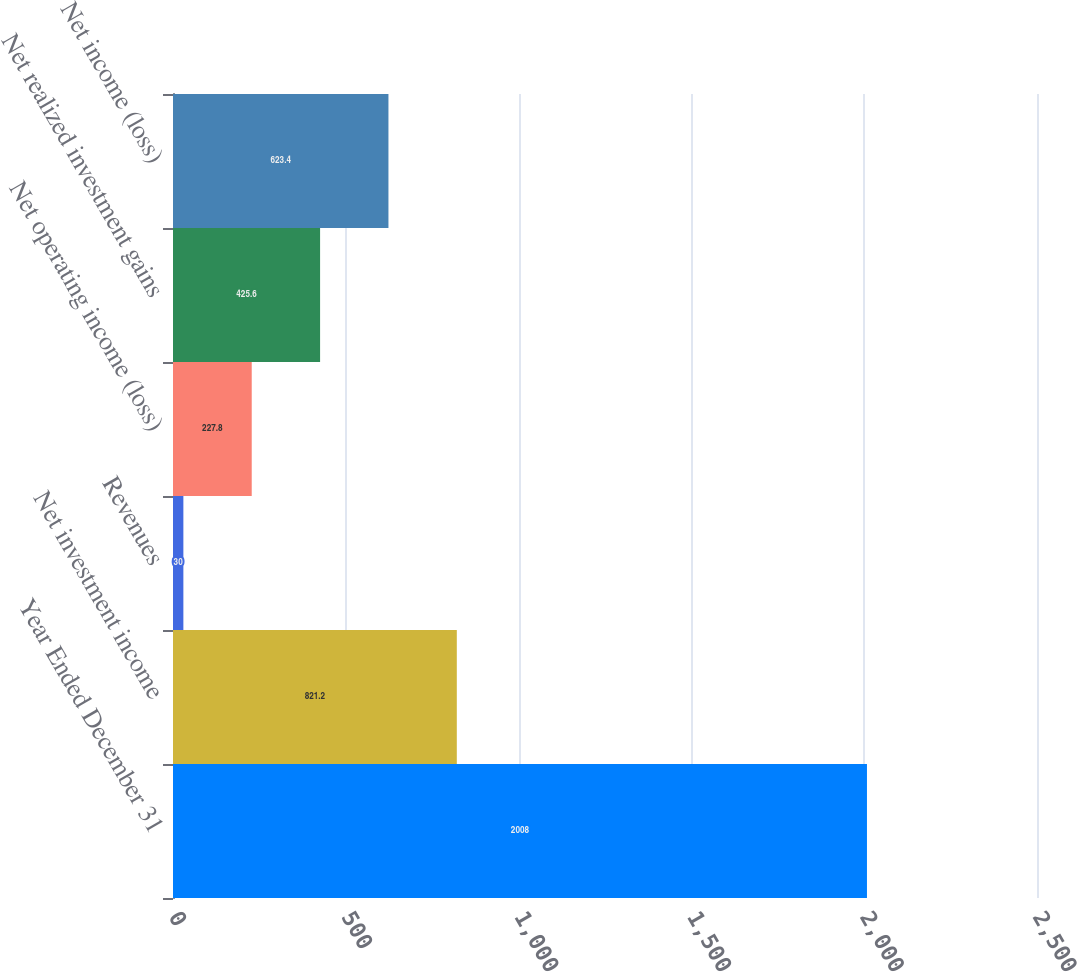Convert chart to OTSL. <chart><loc_0><loc_0><loc_500><loc_500><bar_chart><fcel>Year Ended December 31<fcel>Net investment income<fcel>Revenues<fcel>Net operating income (loss)<fcel>Net realized investment gains<fcel>Net income (loss)<nl><fcel>2008<fcel>821.2<fcel>30<fcel>227.8<fcel>425.6<fcel>623.4<nl></chart> 